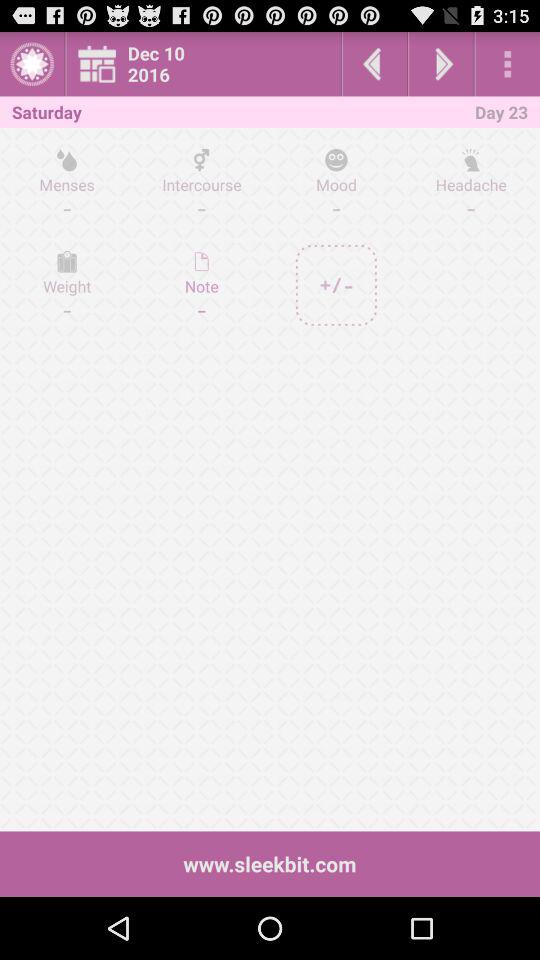Which day is mentioned? The mentioned day is Saturday. 